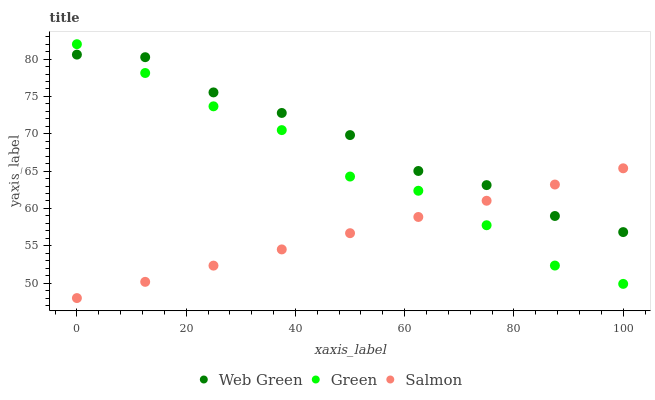Does Salmon have the minimum area under the curve?
Answer yes or no. Yes. Does Web Green have the maximum area under the curve?
Answer yes or no. Yes. Does Green have the minimum area under the curve?
Answer yes or no. No. Does Green have the maximum area under the curve?
Answer yes or no. No. Is Salmon the smoothest?
Answer yes or no. Yes. Is Green the roughest?
Answer yes or no. Yes. Is Web Green the smoothest?
Answer yes or no. No. Is Web Green the roughest?
Answer yes or no. No. Does Salmon have the lowest value?
Answer yes or no. Yes. Does Green have the lowest value?
Answer yes or no. No. Does Green have the highest value?
Answer yes or no. Yes. Does Web Green have the highest value?
Answer yes or no. No. Does Salmon intersect Green?
Answer yes or no. Yes. Is Salmon less than Green?
Answer yes or no. No. Is Salmon greater than Green?
Answer yes or no. No. 